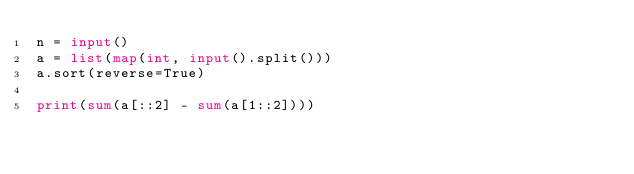Convert code to text. <code><loc_0><loc_0><loc_500><loc_500><_Python_>n = input()
a = list(map(int, input().split()))
a.sort(reverse=True)

print(sum(a[::2] - sum(a[1::2])))</code> 